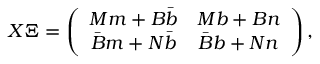<formula> <loc_0><loc_0><loc_500><loc_500>X \Xi = \left ( \begin{array} { c c } { { M m + B \bar { b } } } & { M b + B n } \\ { { \bar { B } m + N \bar { b } } } & { { \bar { B } b + N n } } \end{array} \right ) ,</formula> 